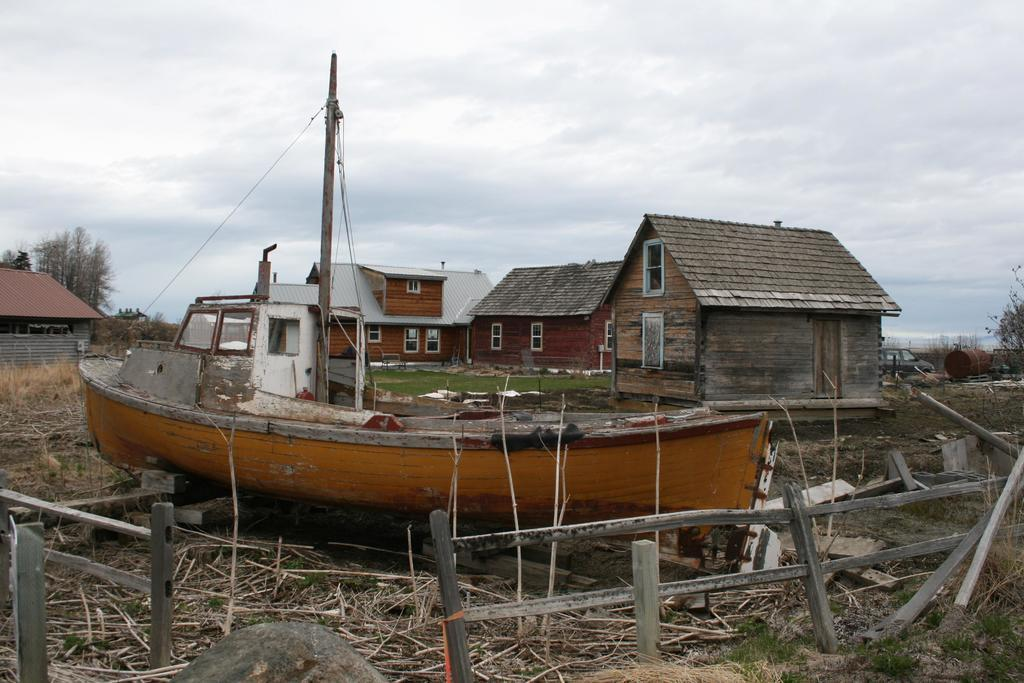What type of structures can be seen in the image? There are sheds in the image. What is located at the bottom of the image? There is a fence at the bottom of the image. What type of natural objects are visible in the image? Twigs are visible in the image. What type of vehicle is present in the image? There is a boat in the image. What type of vegetation can be seen in the background of the image? There are trees in the background of the image. What is visible in the background of the image besides the trees? The sky is visible in the background of the image. What type of transportation is present in the image besides the boat? There is a car in the image. What type of flag is waving on the boat in the image? There is no flag visible on the boat in the image. Can you tell me how many people are swimming in the image? There is no swimming activity depicted in the image. 